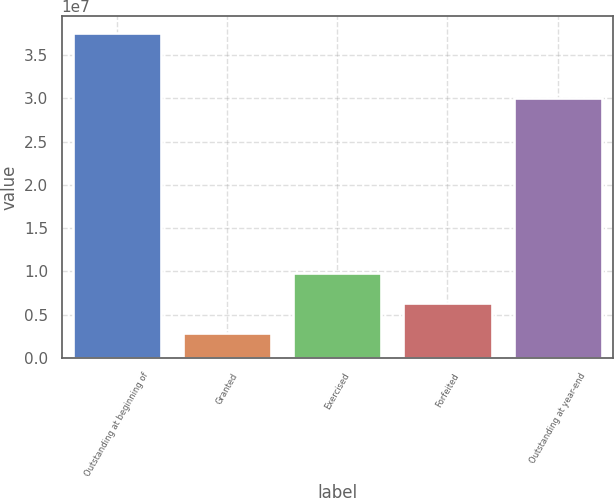<chart> <loc_0><loc_0><loc_500><loc_500><bar_chart><fcel>Outstanding at beginning of<fcel>Granted<fcel>Exercised<fcel>Forfeited<fcel>Outstanding at year-end<nl><fcel>3.75565e+07<fcel>2.95925e+06<fcel>9.87871e+06<fcel>6.41898e+06<fcel>3.0062e+07<nl></chart> 